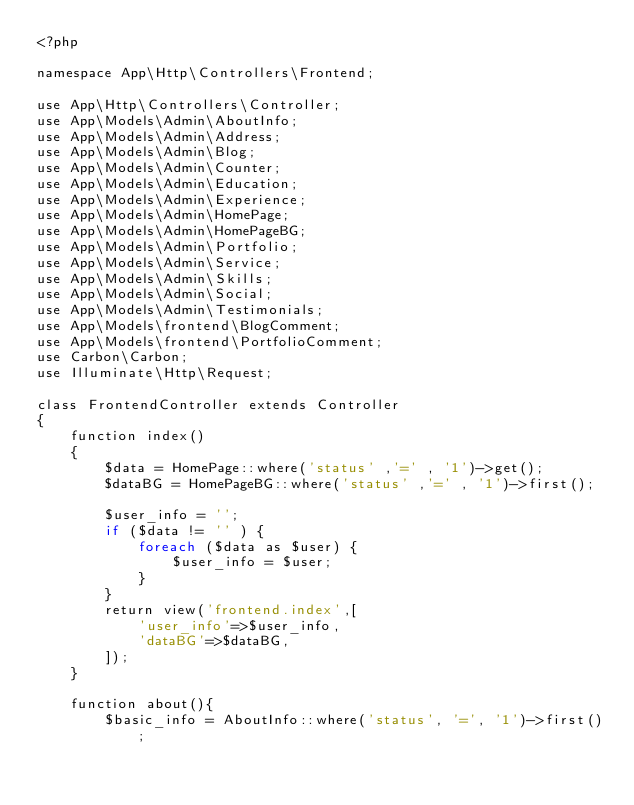<code> <loc_0><loc_0><loc_500><loc_500><_PHP_><?php

namespace App\Http\Controllers\Frontend;

use App\Http\Controllers\Controller;
use App\Models\Admin\AboutInfo;
use App\Models\Admin\Address;
use App\Models\Admin\Blog;
use App\Models\Admin\Counter;
use App\Models\Admin\Education;
use App\Models\Admin\Experience;
use App\Models\Admin\HomePage;
use App\Models\Admin\HomePageBG;
use App\Models\Admin\Portfolio;
use App\Models\Admin\Service;
use App\Models\Admin\Skills;
use App\Models\Admin\Social;
use App\Models\Admin\Testimonials;
use App\Models\frontend\BlogComment;
use App\Models\frontend\PortfolioComment;
use Carbon\Carbon;
use Illuminate\Http\Request;

class FrontendController extends Controller
{
    function index()
    {
        $data = HomePage::where('status' ,'=' , '1')->get();
        $dataBG = HomePageBG::where('status' ,'=' , '1')->first();

        $user_info = '';
        if ($data != '' ) {
            foreach ($data as $user) {
                $user_info = $user;
            }
        }
        return view('frontend.index',[
            'user_info'=>$user_info,
            'dataBG'=>$dataBG,
        ]);
    }

    function about(){
        $basic_info = AboutInfo::where('status', '=', '1')->first();</code> 